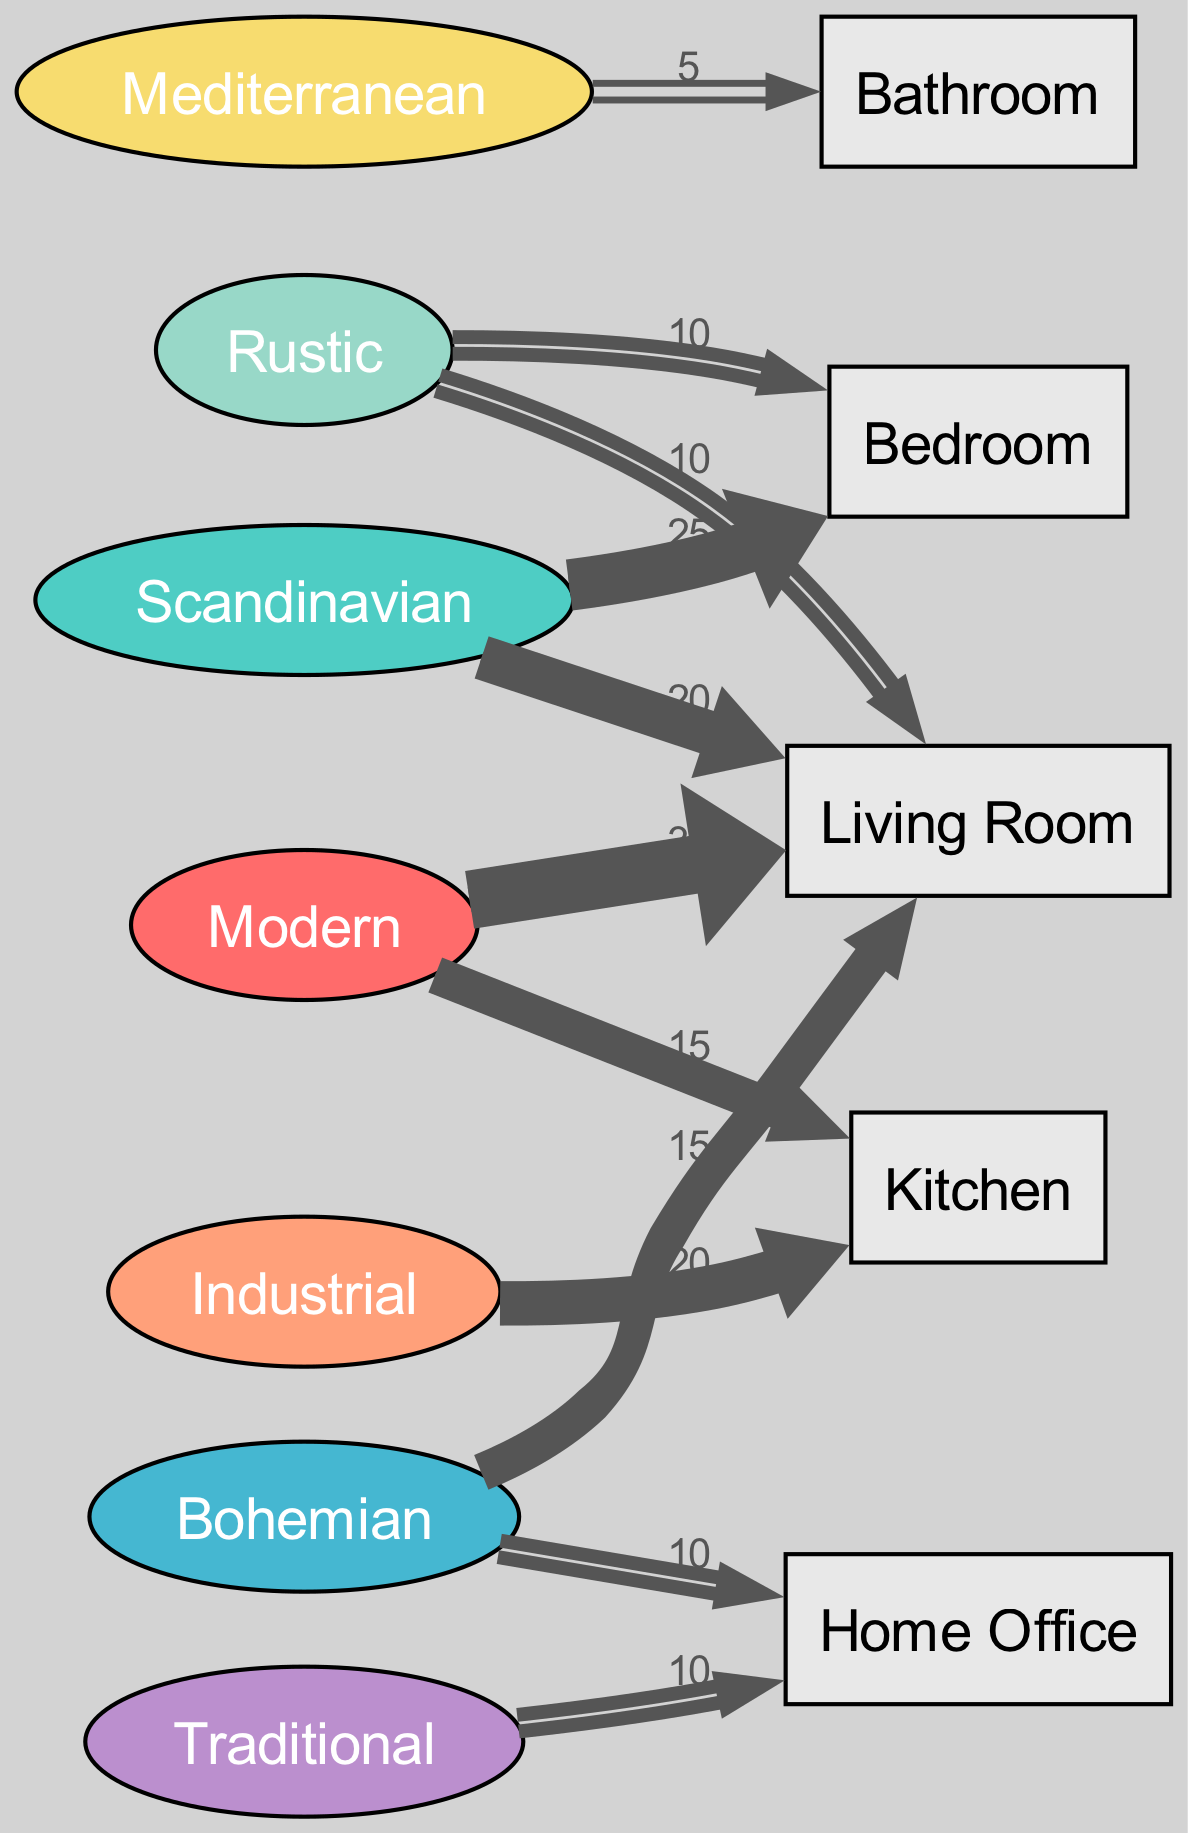What is the highest value flow from a décor style to a room? The highest value flow is the one from Modern to Living Room, which has a value of 30. This can be determined by reviewing the links in the diagram and identifying the flow with the largest value.
Answer: 30 Which room has the most varied décor styles flowing into it? The Living Room has three different styles flowing into it: Modern (30), Bohemian (15), and Rustic (10). By counting the sources linked to the Living Room, it is clear that it receives the most inputs from various styles.
Answer: Living Room How many total connections (edges) are present in the diagram? There are six connections in total as identified from the links in the data provided. By just counting the entries in the 'links' section of the data, we can find this number.
Answer: 6 Which style has the least number of connections to rooms? The Mediterranean style has the least connections, with only one link directed to the Bathroom, as determined by examining the sources linked to various rooms.
Answer: Mediterranean What is the flow from Scandinavian to the Living Room? The flow from Scandinavian to the Living Room has a value of 20. This was found by selecting the specific link associated with the Scandinavian style directed to this room in the diagram.
Answer: 20 What percentage of total links does the flow from Modern to the Kitchen represent? To find this, first we add all the values of the links which totals 115, then calculate (15/115) * 100, which gives us approximately 13.04%. The value of 15 for the Modern to Kitchen link is divided by the total value to find this percentage.
Answer: 13.04% Which room has a connection to the Industrial style, and what is that value? The Kitchen has a connection to the Industrial style with a flow value of 20. This came from identifying the specific link from Industrial to Kitchen in the diagram.
Answer: Kitchen, 20 What do the connections to the Home Office indicate about the decor style preferences for that room? The Home Office has connections to two décor styles: Traditional (10) and Bohemian (10). This indicates that there is a balanced preference between these two styles for the Home Office, as shown by the equal value flows.
Answer: Traditional, Bohemian 